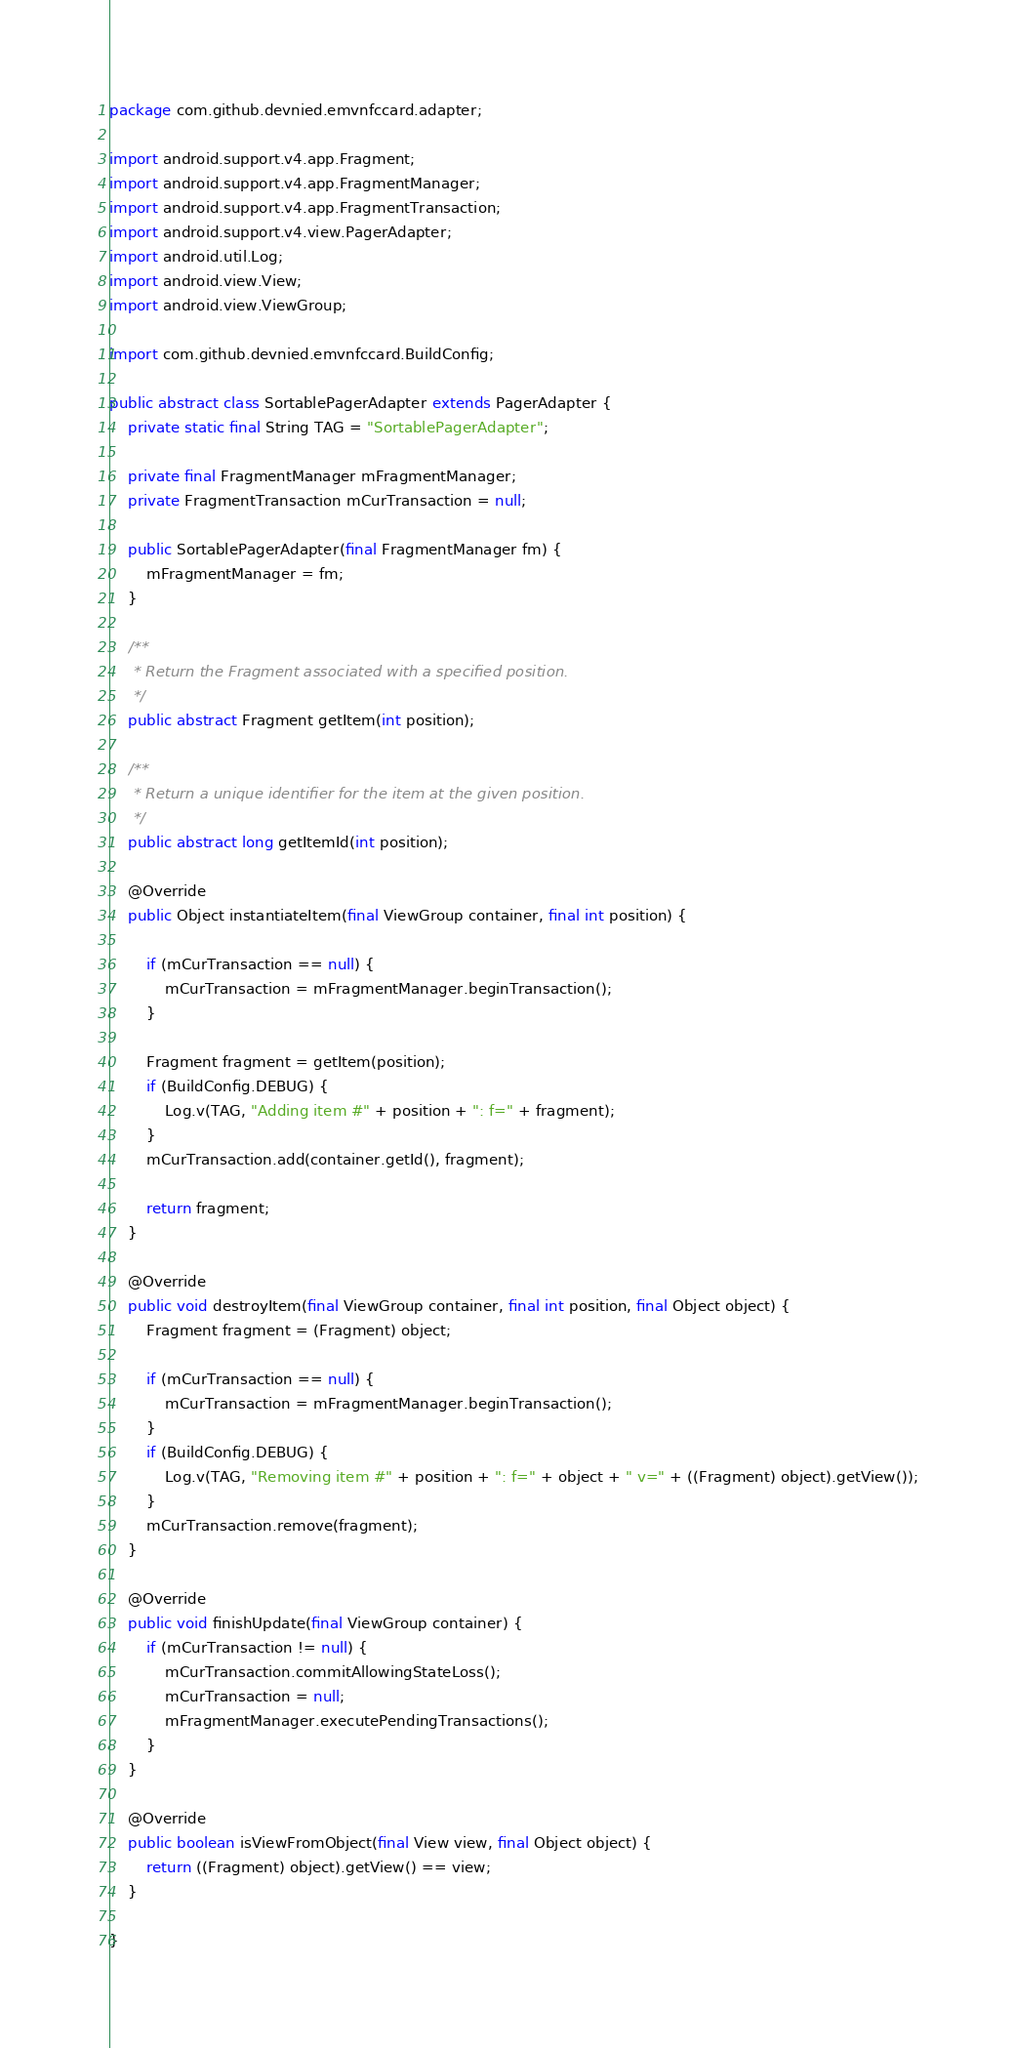<code> <loc_0><loc_0><loc_500><loc_500><_Java_>package com.github.devnied.emvnfccard.adapter;

import android.support.v4.app.Fragment;
import android.support.v4.app.FragmentManager;
import android.support.v4.app.FragmentTransaction;
import android.support.v4.view.PagerAdapter;
import android.util.Log;
import android.view.View;
import android.view.ViewGroup;

import com.github.devnied.emvnfccard.BuildConfig;

public abstract class SortablePagerAdapter extends PagerAdapter {
	private static final String TAG = "SortablePagerAdapter";

	private final FragmentManager mFragmentManager;
	private FragmentTransaction mCurTransaction = null;

	public SortablePagerAdapter(final FragmentManager fm) {
		mFragmentManager = fm;
	}

	/**
	 * Return the Fragment associated with a specified position.
	 */
	public abstract Fragment getItem(int position);

	/**
	 * Return a unique identifier for the item at the given position.
	 */
	public abstract long getItemId(int position);

	@Override
	public Object instantiateItem(final ViewGroup container, final int position) {

		if (mCurTransaction == null) {
			mCurTransaction = mFragmentManager.beginTransaction();
		}

		Fragment fragment = getItem(position);
		if (BuildConfig.DEBUG) {
			Log.v(TAG, "Adding item #" + position + ": f=" + fragment);
		}
		mCurTransaction.add(container.getId(), fragment);

		return fragment;
	}

	@Override
	public void destroyItem(final ViewGroup container, final int position, final Object object) {
		Fragment fragment = (Fragment) object;

		if (mCurTransaction == null) {
			mCurTransaction = mFragmentManager.beginTransaction();
		}
		if (BuildConfig.DEBUG) {
			Log.v(TAG, "Removing item #" + position + ": f=" + object + " v=" + ((Fragment) object).getView());
		}
		mCurTransaction.remove(fragment);
	}

	@Override
	public void finishUpdate(final ViewGroup container) {
		if (mCurTransaction != null) {
			mCurTransaction.commitAllowingStateLoss();
			mCurTransaction = null;
			mFragmentManager.executePendingTransactions();
		}
	}

	@Override
	public boolean isViewFromObject(final View view, final Object object) {
		return ((Fragment) object).getView() == view;
	}

}</code> 